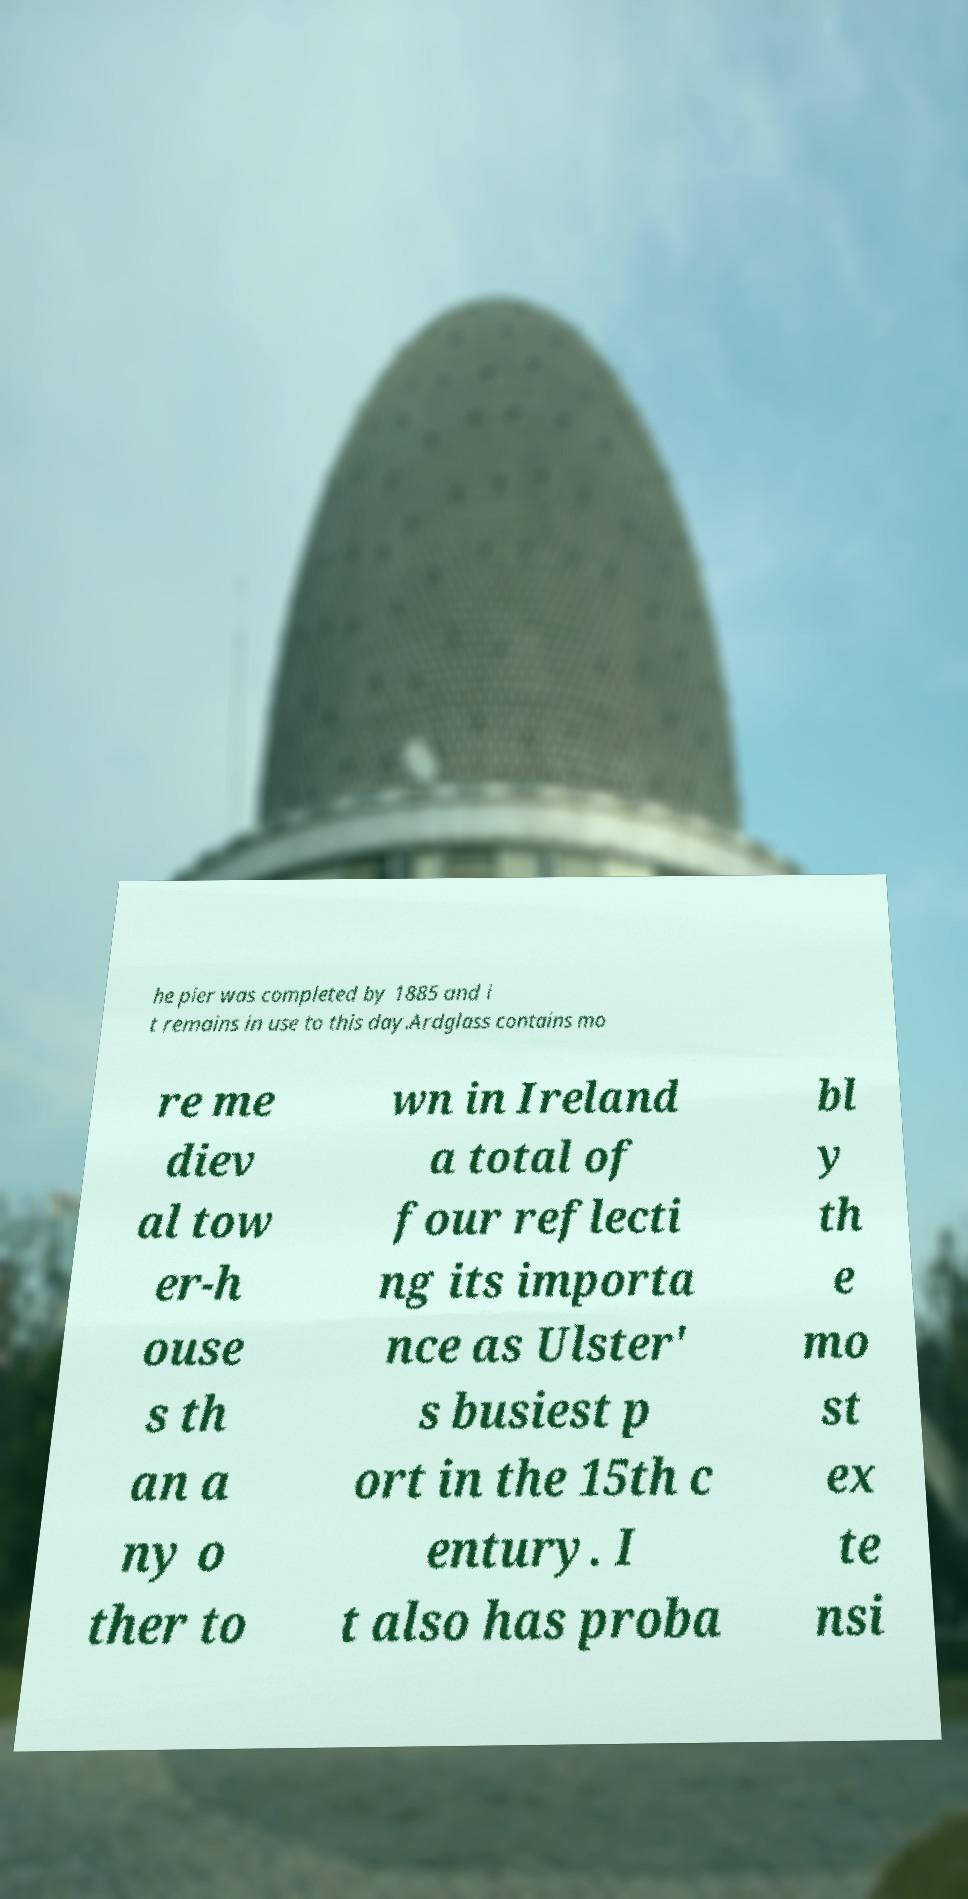There's text embedded in this image that I need extracted. Can you transcribe it verbatim? he pier was completed by 1885 and i t remains in use to this day.Ardglass contains mo re me diev al tow er-h ouse s th an a ny o ther to wn in Ireland a total of four reflecti ng its importa nce as Ulster' s busiest p ort in the 15th c entury. I t also has proba bl y th e mo st ex te nsi 